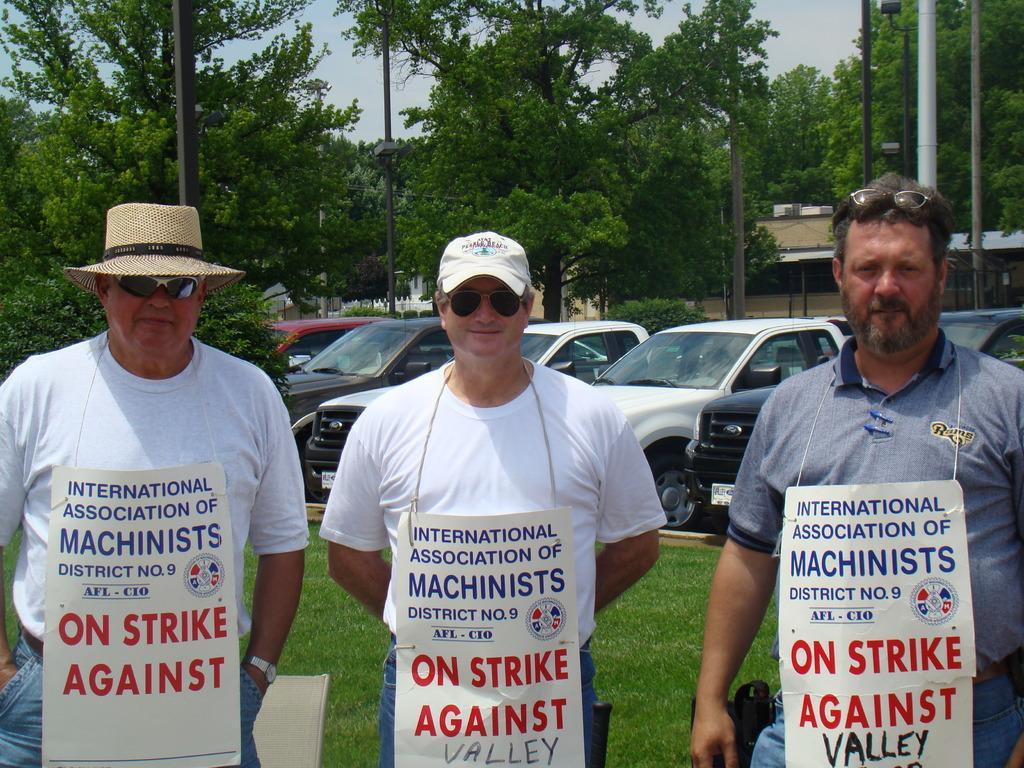In one or two sentences, can you explain what this image depicts? In this image I can see three persons wearing boards are standing on the ground. In the background I can see few vehicles on the ground, few trees which are green in color, few metal poles, few buildings and the sky. 